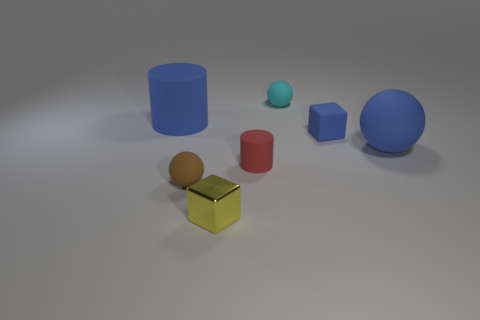Add 2 yellow cubes. How many objects exist? 9 Subtract all balls. How many objects are left? 4 Add 2 small balls. How many small balls are left? 4 Add 4 yellow metallic balls. How many yellow metallic balls exist? 4 Subtract 0 green cylinders. How many objects are left? 7 Subtract all yellow shiny objects. Subtract all red matte things. How many objects are left? 5 